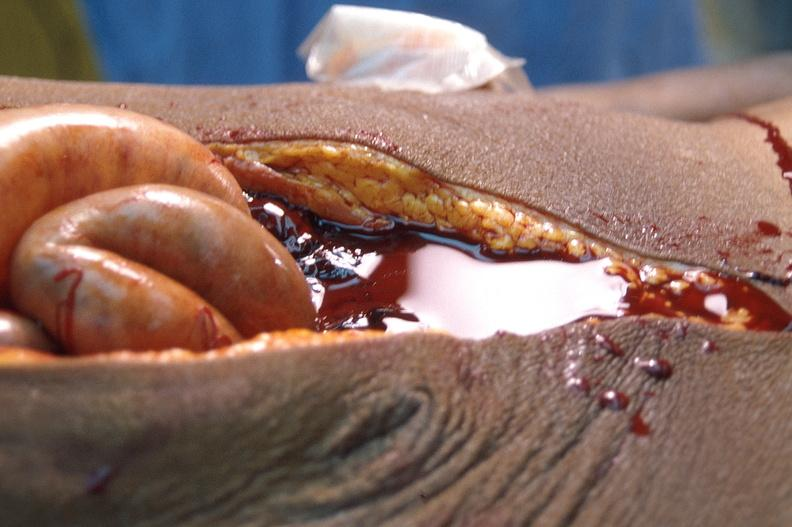does carcinomatosis show ascites?
Answer the question using a single word or phrase. No 